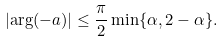<formula> <loc_0><loc_0><loc_500><loc_500>\left | \arg ( - a ) \right | \leq \frac { \pi } { 2 } \min \{ \alpha , 2 - \alpha \} .</formula> 